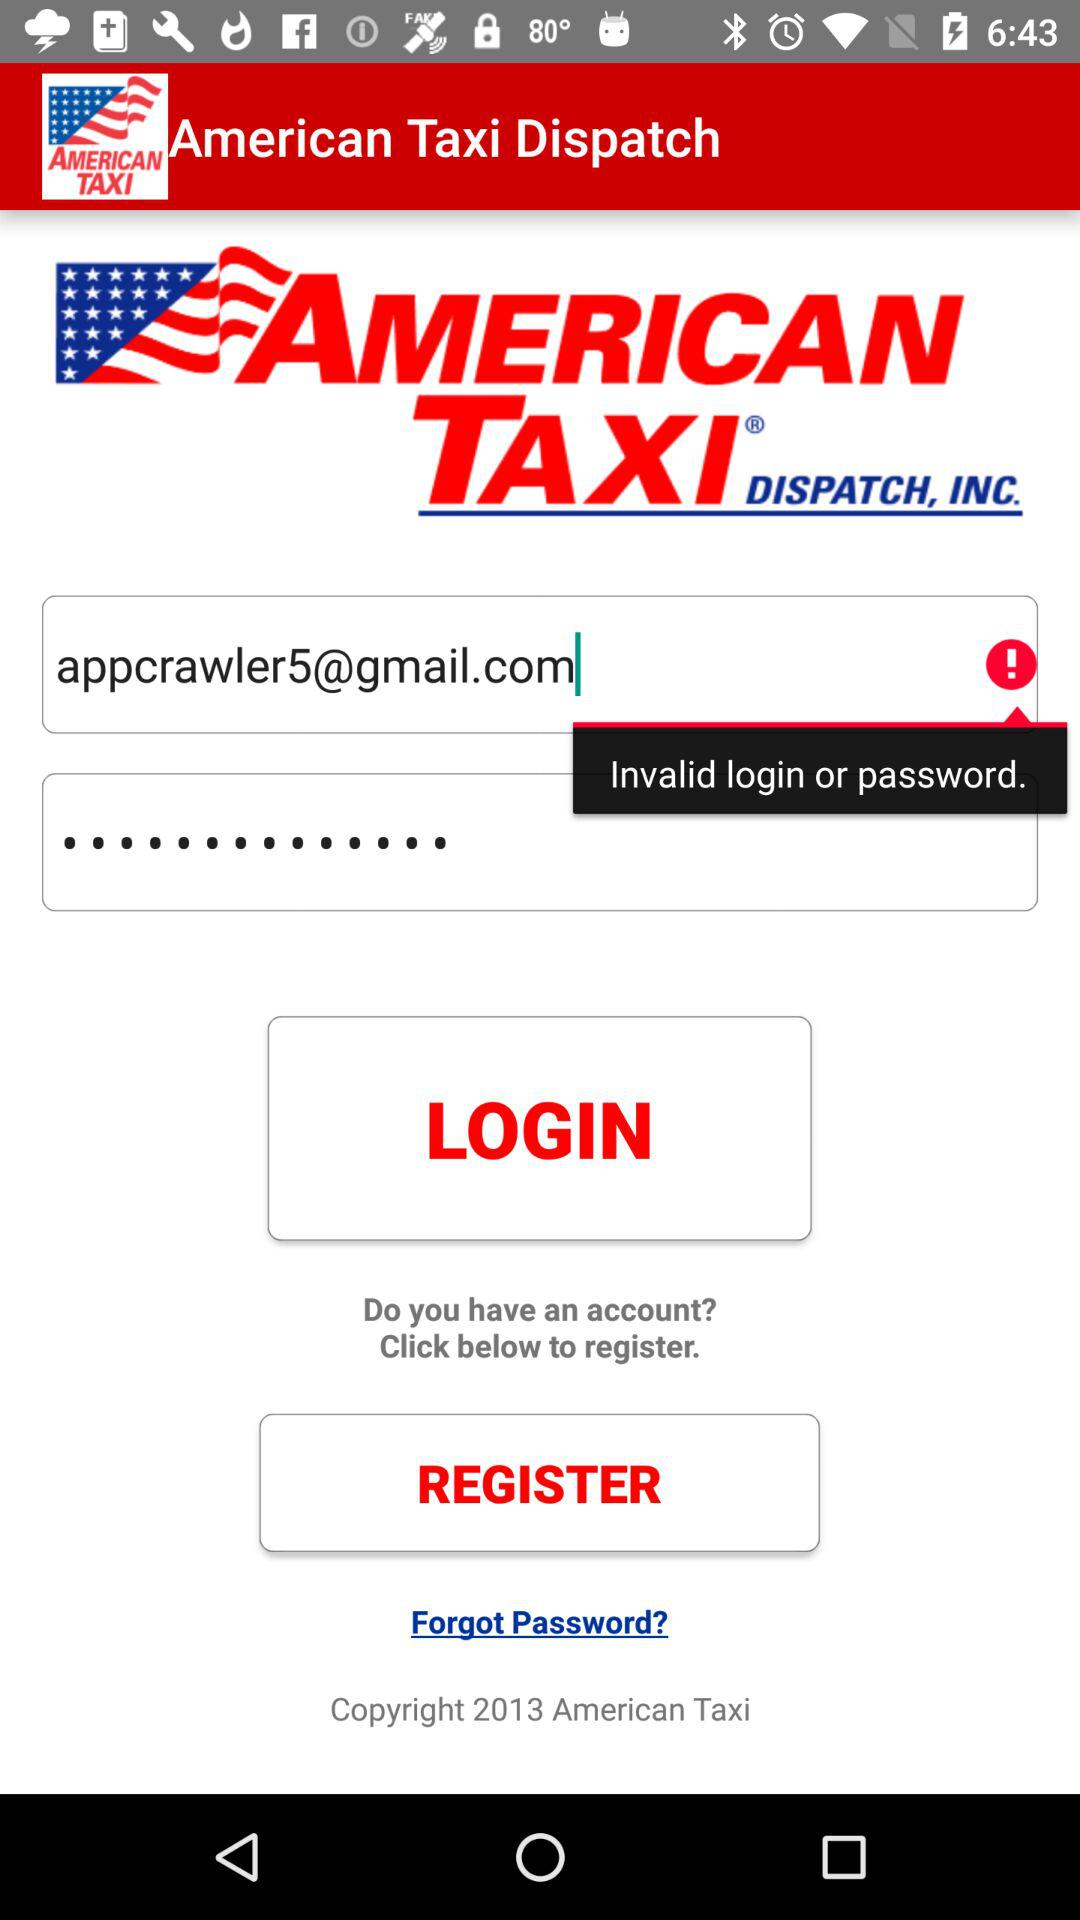What is the name of the application? The name of the application is "American Taxi Dispatch". 